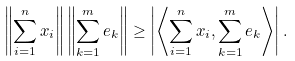Convert formula to latex. <formula><loc_0><loc_0><loc_500><loc_500>\left \| \sum _ { i = 1 } ^ { n } x _ { i } \right \| \left \| \sum _ { k = 1 } ^ { m } e _ { k } \right \| \geq \left | \left \langle \sum _ { i = 1 } ^ { n } x _ { i } , \sum _ { k = 1 } ^ { m } e _ { k } \right \rangle \right | .</formula> 